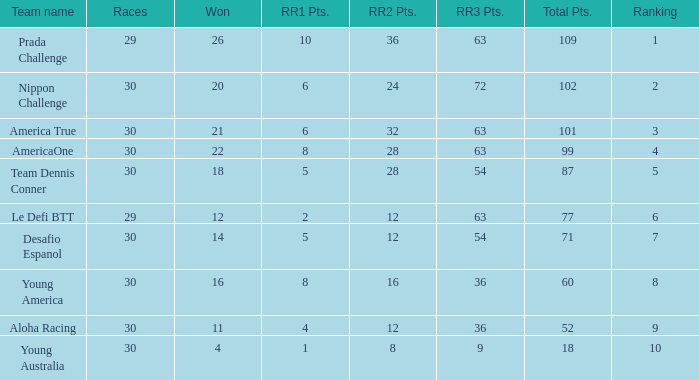Name the ranking for rr2 pts being 8 10.0. 